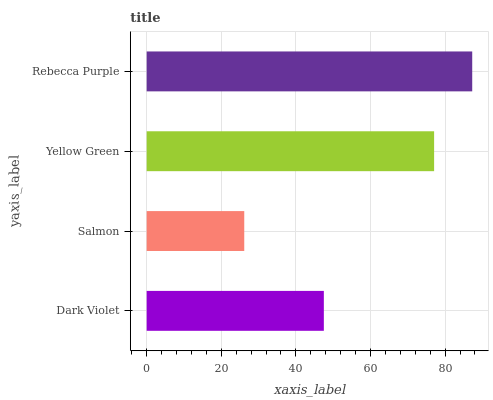Is Salmon the minimum?
Answer yes or no. Yes. Is Rebecca Purple the maximum?
Answer yes or no. Yes. Is Yellow Green the minimum?
Answer yes or no. No. Is Yellow Green the maximum?
Answer yes or no. No. Is Yellow Green greater than Salmon?
Answer yes or no. Yes. Is Salmon less than Yellow Green?
Answer yes or no. Yes. Is Salmon greater than Yellow Green?
Answer yes or no. No. Is Yellow Green less than Salmon?
Answer yes or no. No. Is Yellow Green the high median?
Answer yes or no. Yes. Is Dark Violet the low median?
Answer yes or no. Yes. Is Dark Violet the high median?
Answer yes or no. No. Is Rebecca Purple the low median?
Answer yes or no. No. 